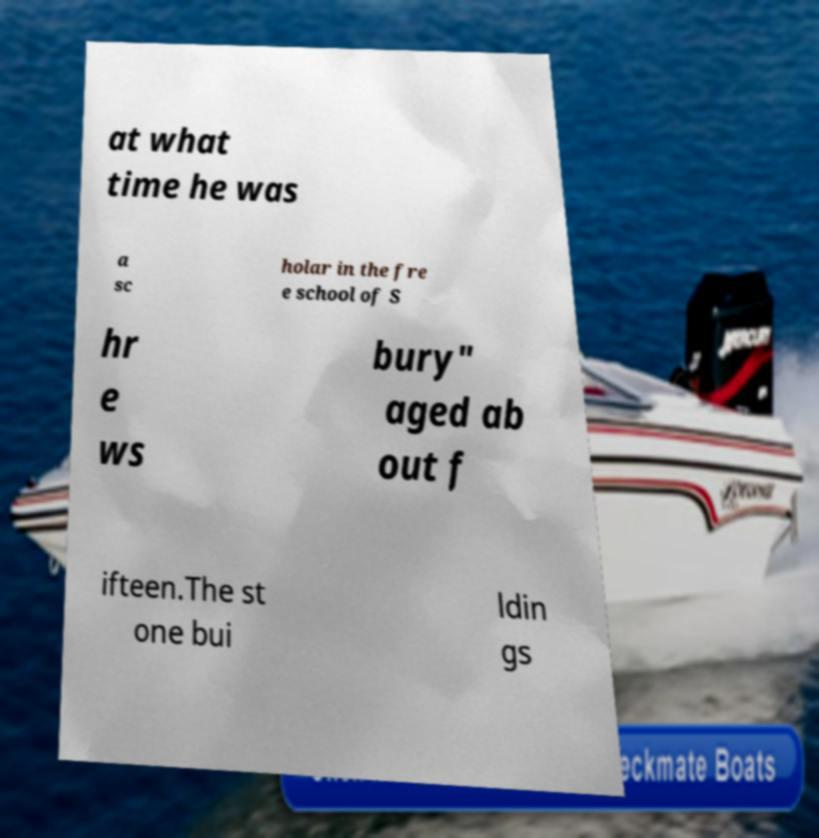Can you accurately transcribe the text from the provided image for me? at what time he was a sc holar in the fre e school of S hr e ws bury" aged ab out f ifteen.The st one bui ldin gs 